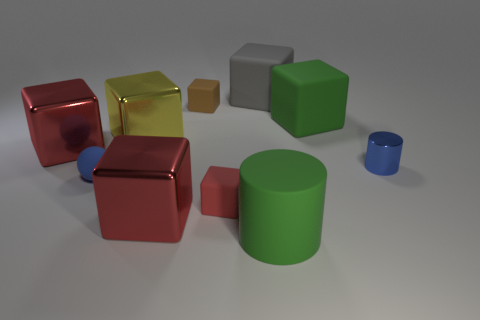Are there any yellow metal objects?
Provide a succinct answer. Yes. How big is the red block that is left of the red matte cube and in front of the blue cylinder?
Your response must be concise. Large. Are there more small blue cylinders behind the large gray object than large gray blocks in front of the red matte thing?
Give a very brief answer. No. What size is the matte object that is the same color as the small metallic cylinder?
Your answer should be compact. Small. The tiny sphere has what color?
Your response must be concise. Blue. There is a big matte thing that is behind the green matte cylinder and in front of the big gray thing; what is its color?
Make the answer very short. Green. What is the color of the large rubber cube that is right of the green object in front of the matte block that is on the right side of the gray block?
Give a very brief answer. Green. There is a metal cylinder that is the same size as the rubber sphere; what color is it?
Ensure brevity in your answer.  Blue. What is the shape of the small blue thing that is to the left of the green thing in front of the big green matte thing that is behind the small cylinder?
Give a very brief answer. Sphere. There is a tiny shiny object that is the same color as the small matte ball; what is its shape?
Give a very brief answer. Cylinder. 